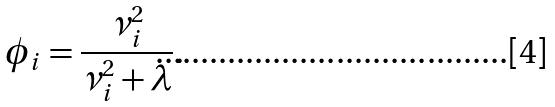<formula> <loc_0><loc_0><loc_500><loc_500>\phi _ { i } = \frac { \nu _ { i } ^ { 2 } } { \nu _ { i } ^ { 2 } + \lambda } .</formula> 